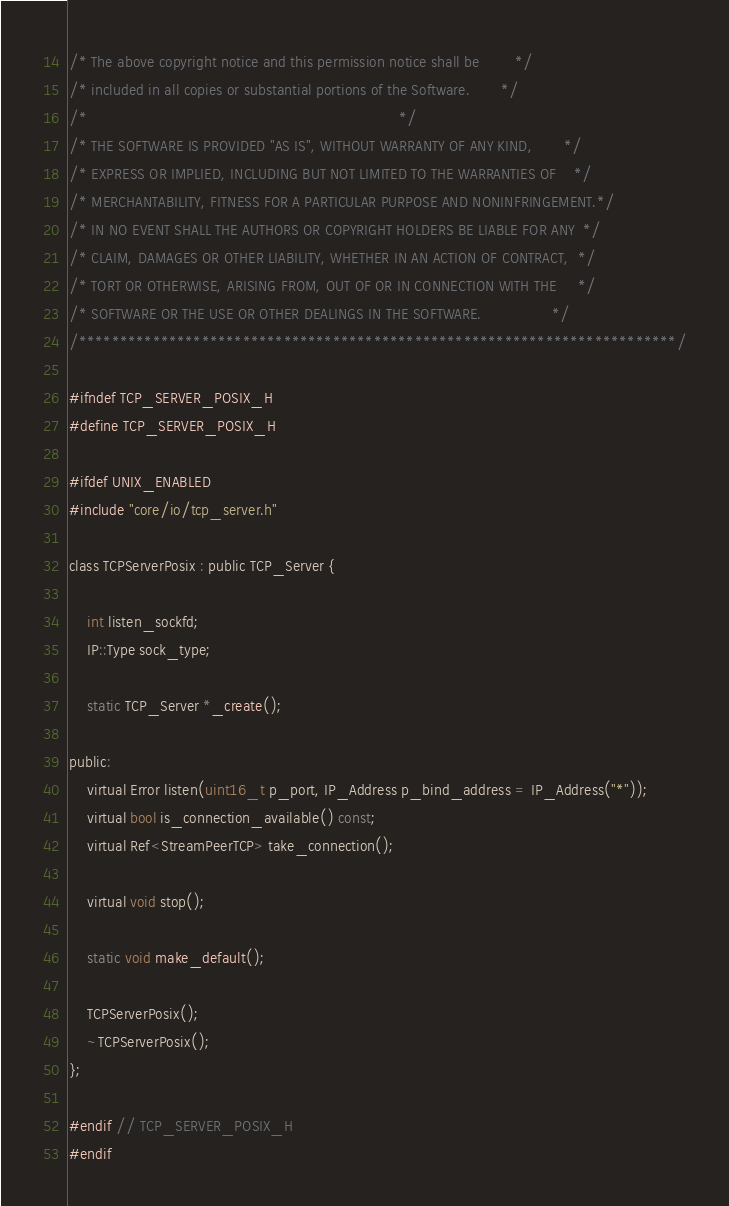Convert code to text. <code><loc_0><loc_0><loc_500><loc_500><_C_>/* The above copyright notice and this permission notice shall be        */
/* included in all copies or substantial portions of the Software.       */
/*                                                                       */
/* THE SOFTWARE IS PROVIDED "AS IS", WITHOUT WARRANTY OF ANY KIND,       */
/* EXPRESS OR IMPLIED, INCLUDING BUT NOT LIMITED TO THE WARRANTIES OF    */
/* MERCHANTABILITY, FITNESS FOR A PARTICULAR PURPOSE AND NONINFRINGEMENT.*/
/* IN NO EVENT SHALL THE AUTHORS OR COPYRIGHT HOLDERS BE LIABLE FOR ANY  */
/* CLAIM, DAMAGES OR OTHER LIABILITY, WHETHER IN AN ACTION OF CONTRACT,  */
/* TORT OR OTHERWISE, ARISING FROM, OUT OF OR IN CONNECTION WITH THE     */
/* SOFTWARE OR THE USE OR OTHER DEALINGS IN THE SOFTWARE.                */
/*************************************************************************/

#ifndef TCP_SERVER_POSIX_H
#define TCP_SERVER_POSIX_H

#ifdef UNIX_ENABLED
#include "core/io/tcp_server.h"

class TCPServerPosix : public TCP_Server {

	int listen_sockfd;
	IP::Type sock_type;

	static TCP_Server *_create();

public:
	virtual Error listen(uint16_t p_port, IP_Address p_bind_address = IP_Address("*"));
	virtual bool is_connection_available() const;
	virtual Ref<StreamPeerTCP> take_connection();

	virtual void stop();

	static void make_default();

	TCPServerPosix();
	~TCPServerPosix();
};

#endif // TCP_SERVER_POSIX_H
#endif
</code> 